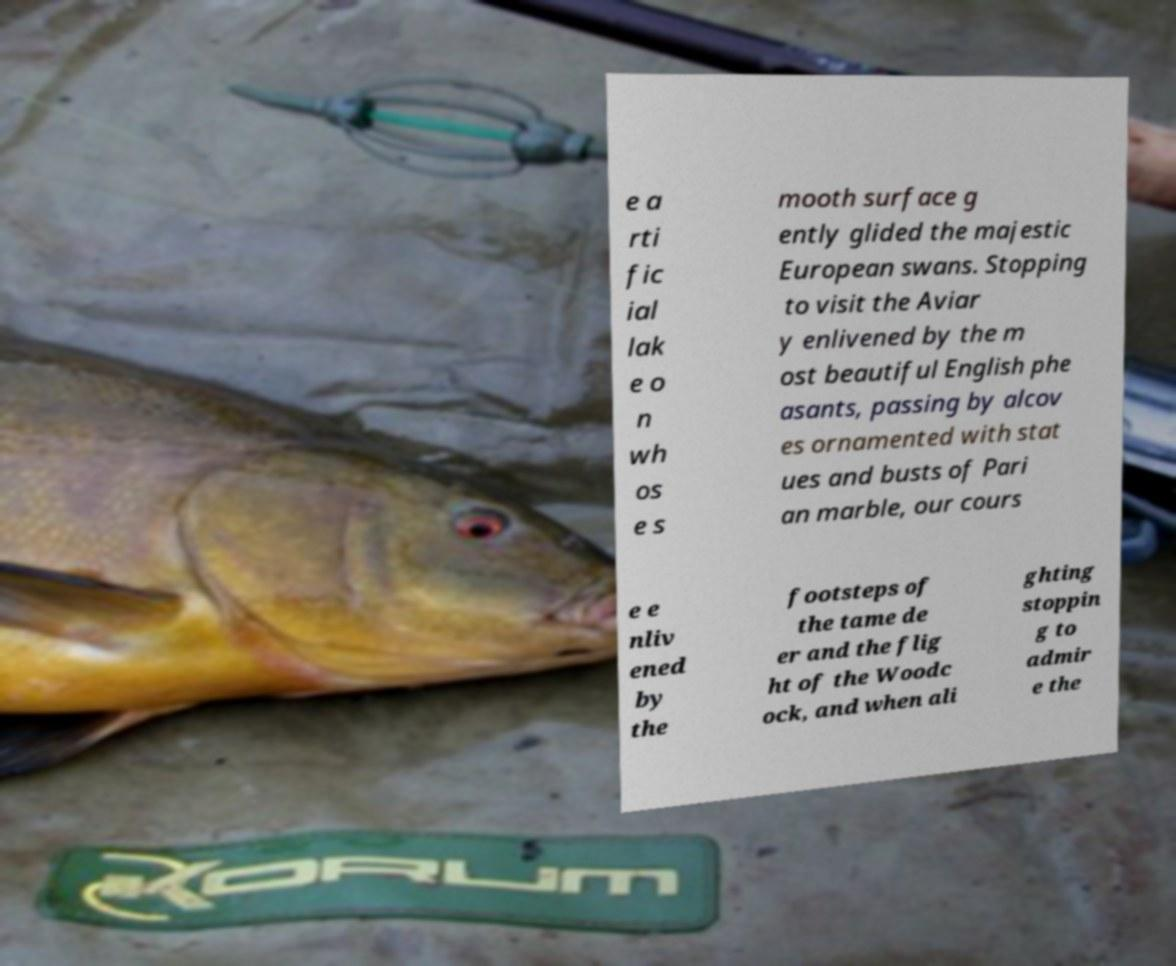What messages or text are displayed in this image? I need them in a readable, typed format. e a rti fic ial lak e o n wh os e s mooth surface g ently glided the majestic European swans. Stopping to visit the Aviar y enlivened by the m ost beautiful English phe asants, passing by alcov es ornamented with stat ues and busts of Pari an marble, our cours e e nliv ened by the footsteps of the tame de er and the flig ht of the Woodc ock, and when ali ghting stoppin g to admir e the 